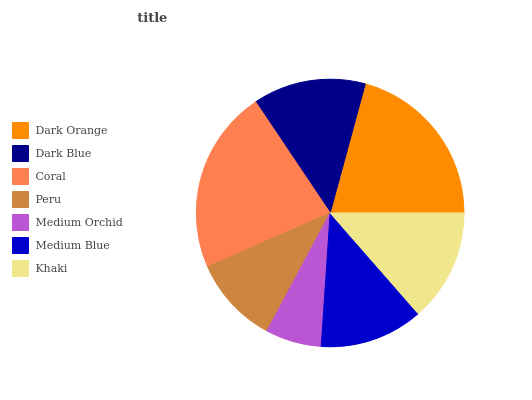Is Medium Orchid the minimum?
Answer yes or no. Yes. Is Coral the maximum?
Answer yes or no. Yes. Is Dark Blue the minimum?
Answer yes or no. No. Is Dark Blue the maximum?
Answer yes or no. No. Is Dark Orange greater than Dark Blue?
Answer yes or no. Yes. Is Dark Blue less than Dark Orange?
Answer yes or no. Yes. Is Dark Blue greater than Dark Orange?
Answer yes or no. No. Is Dark Orange less than Dark Blue?
Answer yes or no. No. Is Khaki the high median?
Answer yes or no. Yes. Is Khaki the low median?
Answer yes or no. Yes. Is Medium Orchid the high median?
Answer yes or no. No. Is Coral the low median?
Answer yes or no. No. 